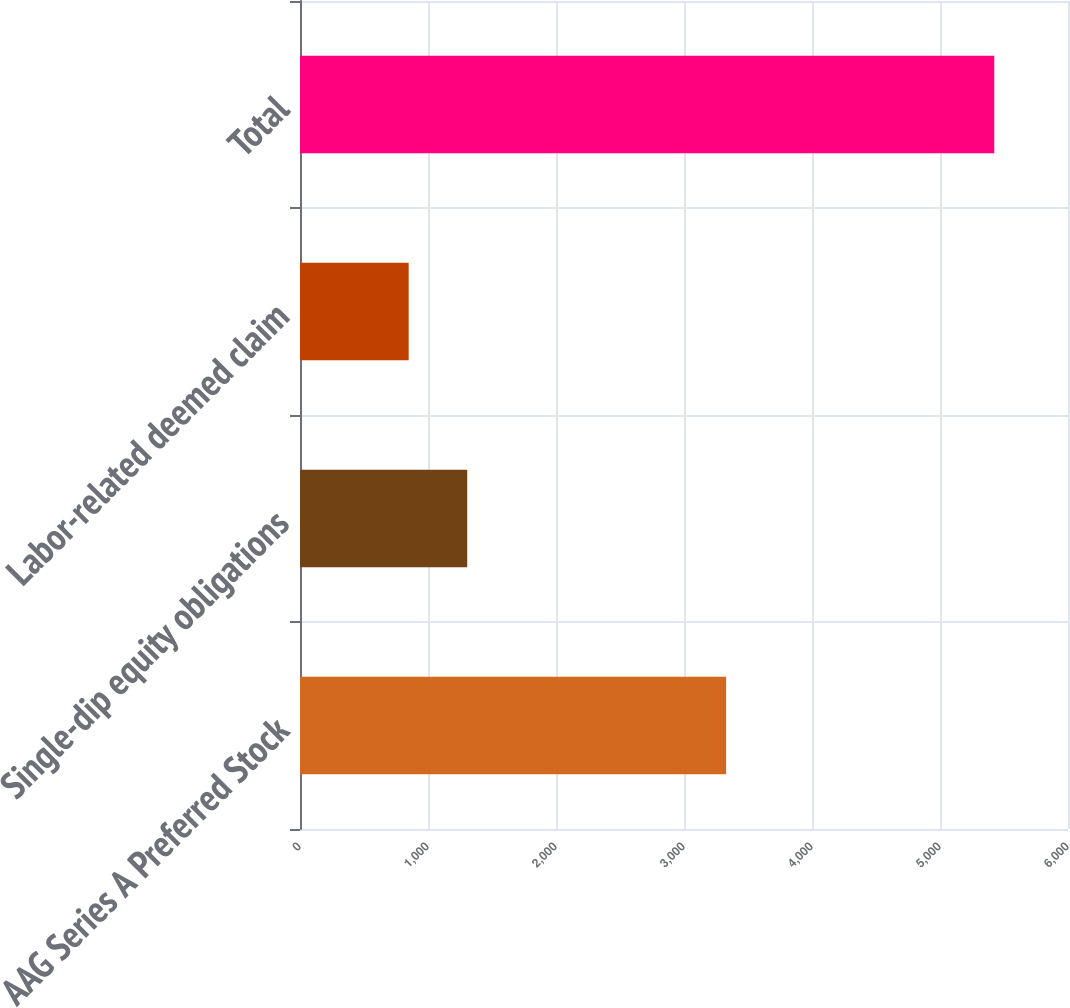Convert chart. <chart><loc_0><loc_0><loc_500><loc_500><bar_chart><fcel>AAG Series A Preferred Stock<fcel>Single-dip equity obligations<fcel>Labor-related deemed claim<fcel>Total<nl><fcel>3329<fcel>1306.5<fcel>849<fcel>5424<nl></chart> 